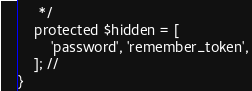Convert code to text. <code><loc_0><loc_0><loc_500><loc_500><_PHP_>     */
    protected $hidden = [
        'password', 'remember_token',
    ]; //
}
</code> 